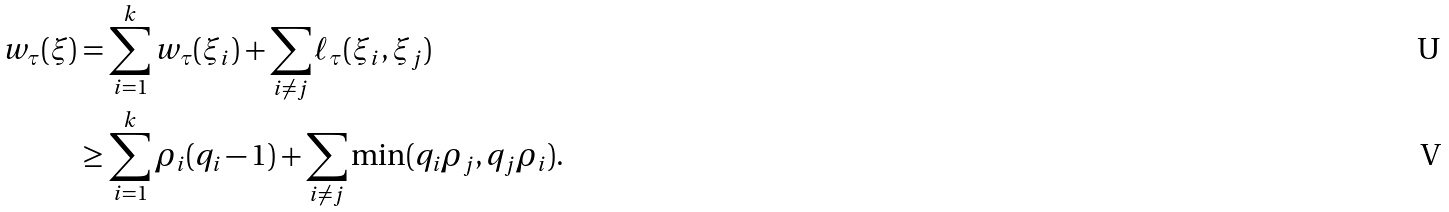<formula> <loc_0><loc_0><loc_500><loc_500>w _ { \tau } ( \xi ) & = \sum _ { i = 1 } ^ { k } w _ { \tau } ( \xi _ { i } ) + \sum _ { i \neq j } \ell _ { \tau } ( \xi _ { i } , \xi _ { j } ) \\ & \geq \sum _ { i = 1 } ^ { k } \rho _ { i } ( q _ { i } - 1 ) + \sum _ { i \neq j } \min ( q _ { i } \rho _ { j } , q _ { j } \rho _ { i } ) .</formula> 